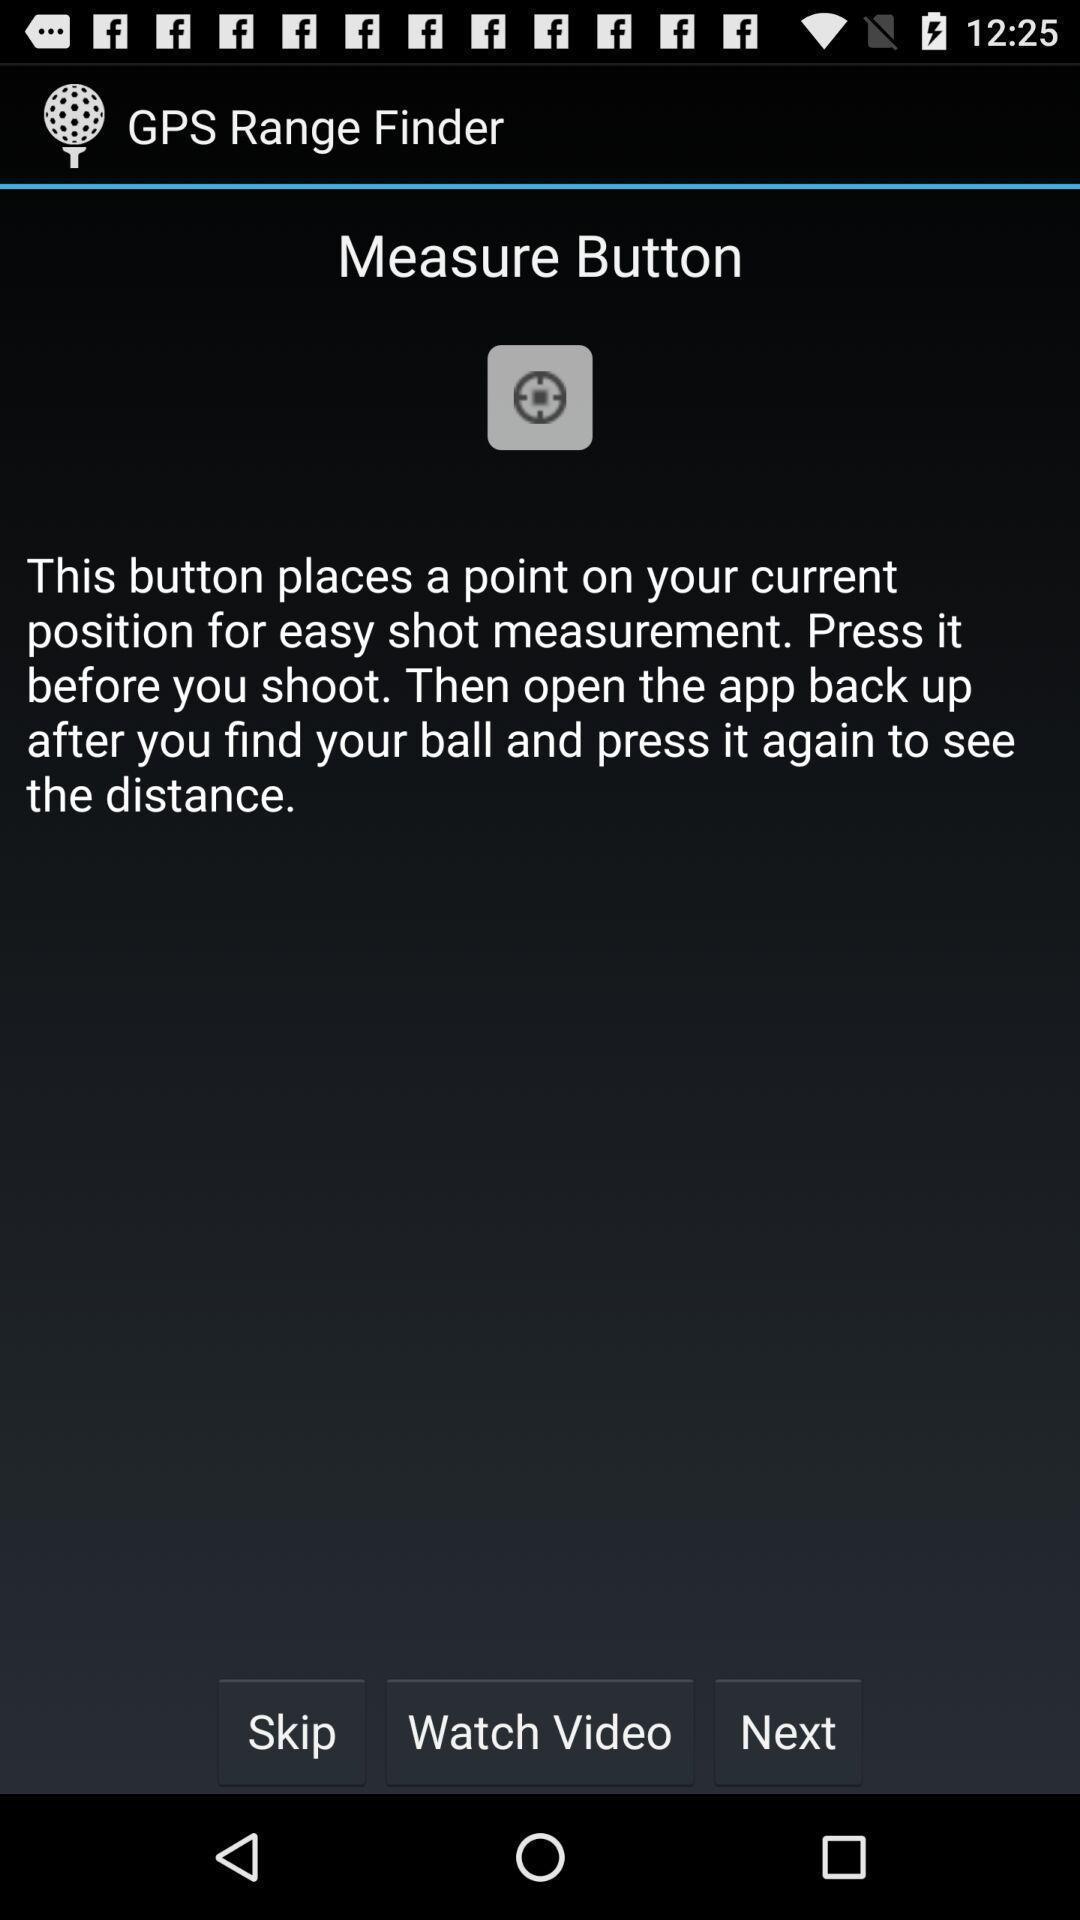What is the overall content of this screenshot? Screen displaying the instruction about measure button. 